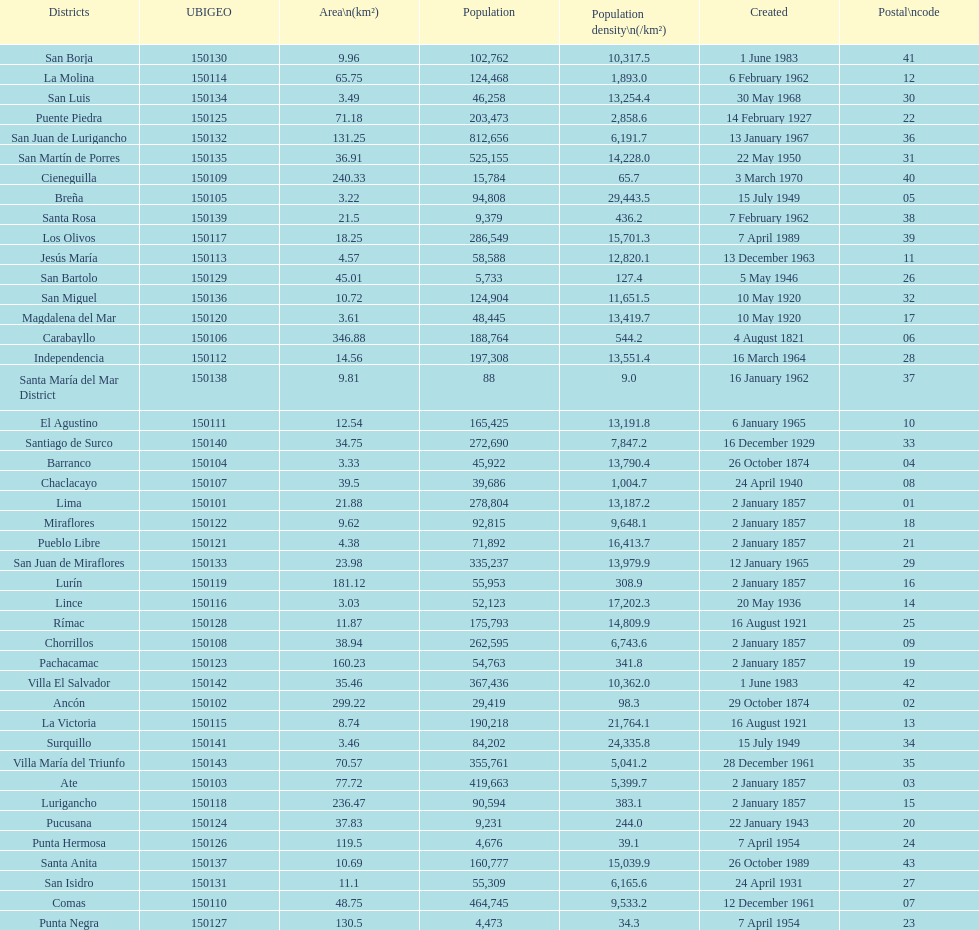How many districts have a population density of at lest 1000.0? 31. 